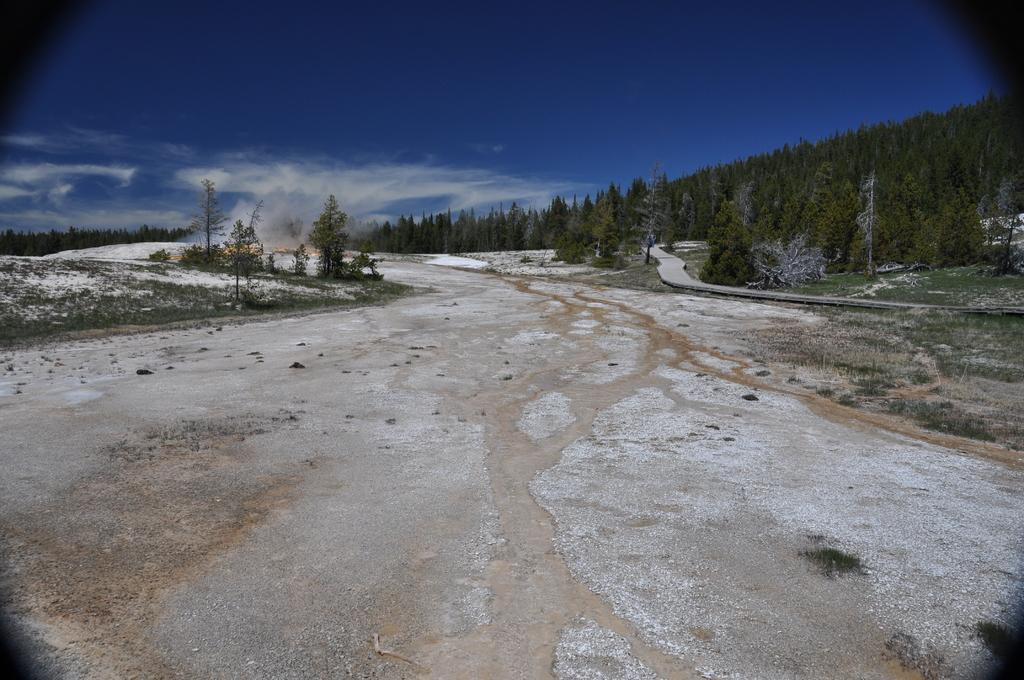In one or two sentences, can you explain what this image depicts? In this picture I can see trees and grass on the ground and I can see blue cloudy sky. 